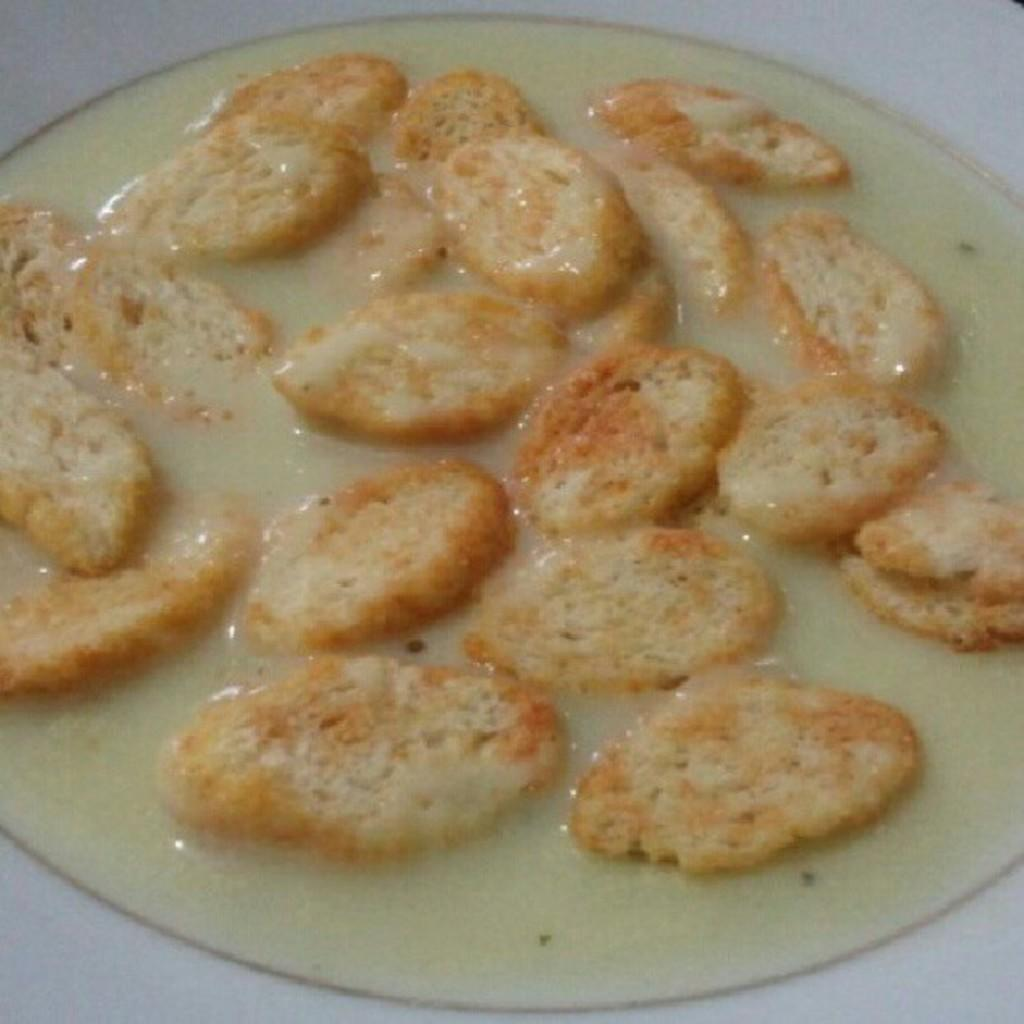What is in the bowl that is visible in the image? There is food in a bowl in the image. Can you see the existence of a tiger in the image? There is no tiger present in the image. What color is the orange in the image? There is no orange present in the image. 